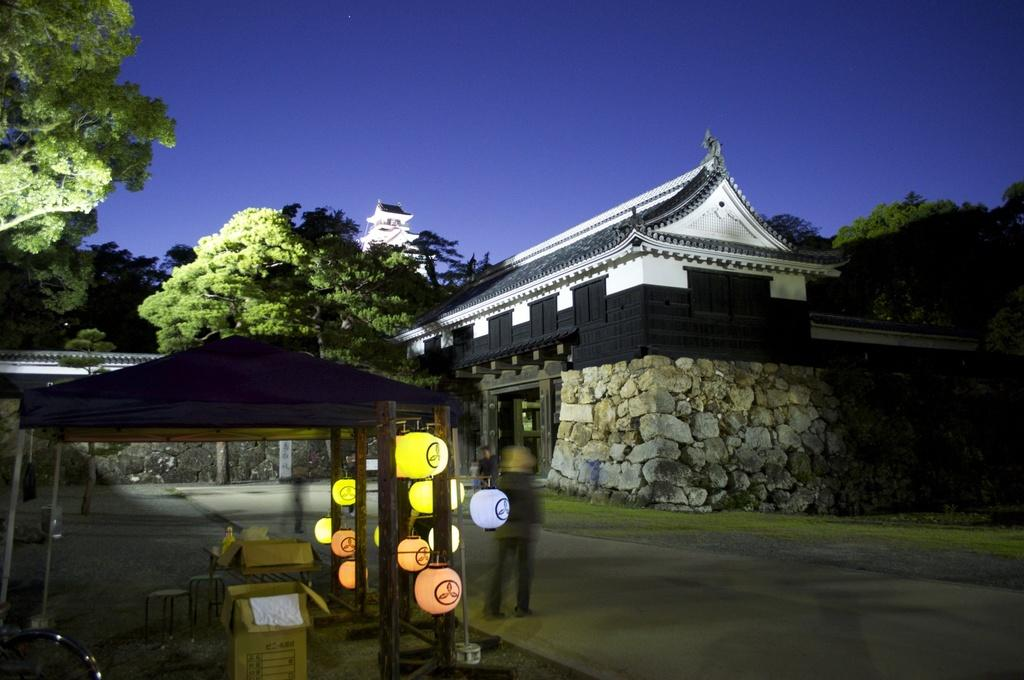What are the people in the image doing? The persons standing on the road are likely waiting or walking. What objects can be seen near the persons? Cardboard cartons are present in the image. What type of seating is available in the image? There are benches in the image. What type of decorative lighting is visible in the image? Paper lanterns are visible in the image. What type of shelter is present in the image? There is a shed in the image. What type of structures are visible in the image? Buildings are present in the image. What type of vegetation is visible in the image? Trees are visible in the image. What part of the natural environment is visible in the image? The sky is visible in the image. What type of shirt is the brake wearing in the image? There is no brake present in the image, and therefore no shirt can be attributed to it. 